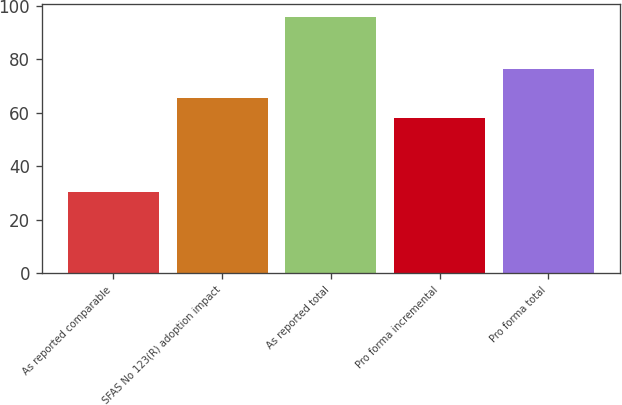<chart> <loc_0><loc_0><loc_500><loc_500><bar_chart><fcel>As reported comparable<fcel>SFAS No 123(R) adoption impact<fcel>As reported total<fcel>Pro forma incremental<fcel>Pro forma total<nl><fcel>30.3<fcel>65.4<fcel>95.7<fcel>57.9<fcel>76.4<nl></chart> 